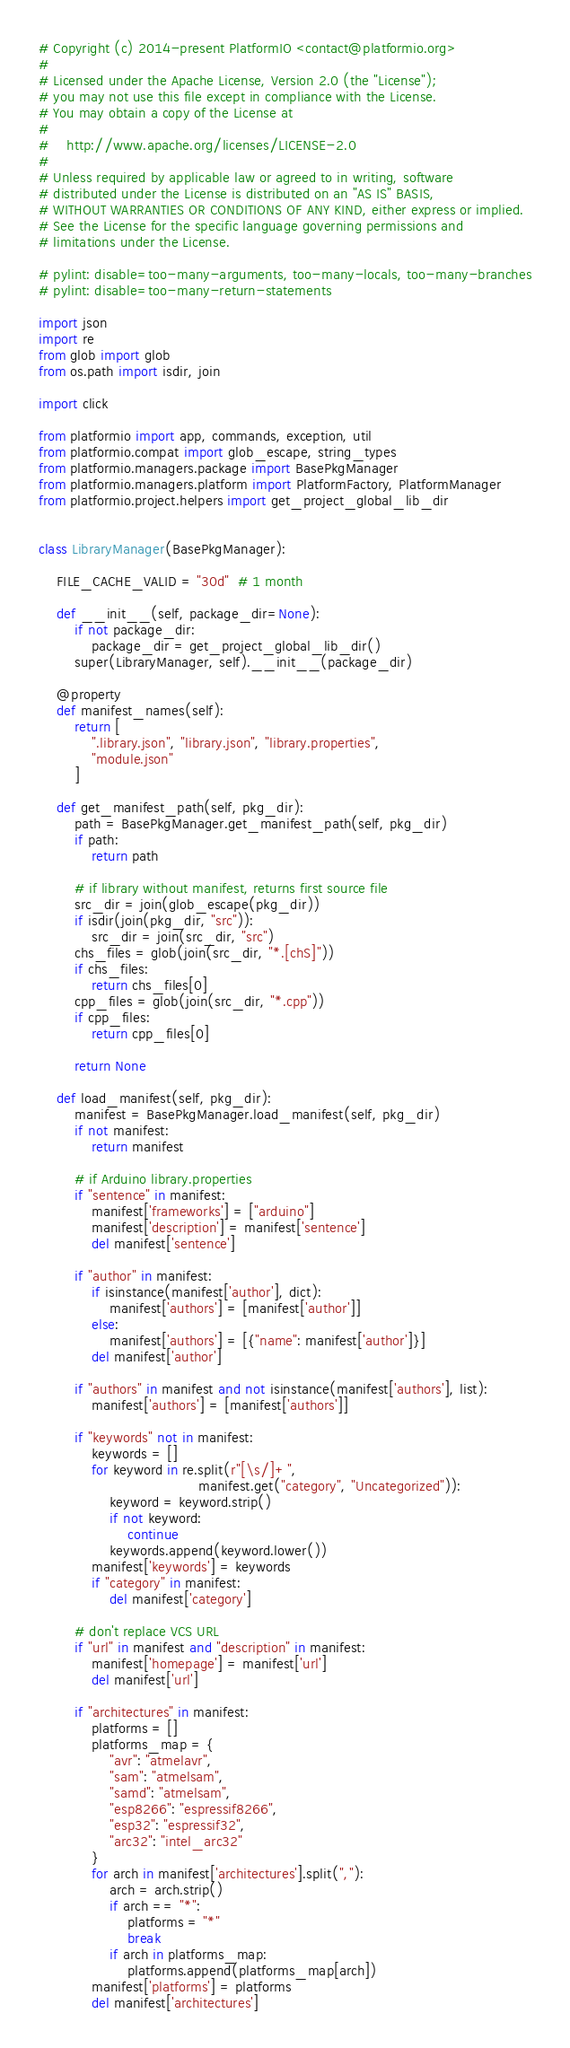<code> <loc_0><loc_0><loc_500><loc_500><_Python_># Copyright (c) 2014-present PlatformIO <contact@platformio.org>
#
# Licensed under the Apache License, Version 2.0 (the "License");
# you may not use this file except in compliance with the License.
# You may obtain a copy of the License at
#
#    http://www.apache.org/licenses/LICENSE-2.0
#
# Unless required by applicable law or agreed to in writing, software
# distributed under the License is distributed on an "AS IS" BASIS,
# WITHOUT WARRANTIES OR CONDITIONS OF ANY KIND, either express or implied.
# See the License for the specific language governing permissions and
# limitations under the License.

# pylint: disable=too-many-arguments, too-many-locals, too-many-branches
# pylint: disable=too-many-return-statements

import json
import re
from glob import glob
from os.path import isdir, join

import click

from platformio import app, commands, exception, util
from platformio.compat import glob_escape, string_types
from platformio.managers.package import BasePkgManager
from platformio.managers.platform import PlatformFactory, PlatformManager
from platformio.project.helpers import get_project_global_lib_dir


class LibraryManager(BasePkgManager):

    FILE_CACHE_VALID = "30d"  # 1 month

    def __init__(self, package_dir=None):
        if not package_dir:
            package_dir = get_project_global_lib_dir()
        super(LibraryManager, self).__init__(package_dir)

    @property
    def manifest_names(self):
        return [
            ".library.json", "library.json", "library.properties",
            "module.json"
        ]

    def get_manifest_path(self, pkg_dir):
        path = BasePkgManager.get_manifest_path(self, pkg_dir)
        if path:
            return path

        # if library without manifest, returns first source file
        src_dir = join(glob_escape(pkg_dir))
        if isdir(join(pkg_dir, "src")):
            src_dir = join(src_dir, "src")
        chs_files = glob(join(src_dir, "*.[chS]"))
        if chs_files:
            return chs_files[0]
        cpp_files = glob(join(src_dir, "*.cpp"))
        if cpp_files:
            return cpp_files[0]

        return None

    def load_manifest(self, pkg_dir):
        manifest = BasePkgManager.load_manifest(self, pkg_dir)
        if not manifest:
            return manifest

        # if Arduino library.properties
        if "sentence" in manifest:
            manifest['frameworks'] = ["arduino"]
            manifest['description'] = manifest['sentence']
            del manifest['sentence']

        if "author" in manifest:
            if isinstance(manifest['author'], dict):
                manifest['authors'] = [manifest['author']]
            else:
                manifest['authors'] = [{"name": manifest['author']}]
            del manifest['author']

        if "authors" in manifest and not isinstance(manifest['authors'], list):
            manifest['authors'] = [manifest['authors']]

        if "keywords" not in manifest:
            keywords = []
            for keyword in re.split(r"[\s/]+",
                                    manifest.get("category", "Uncategorized")):
                keyword = keyword.strip()
                if not keyword:
                    continue
                keywords.append(keyword.lower())
            manifest['keywords'] = keywords
            if "category" in manifest:
                del manifest['category']

        # don't replace VCS URL
        if "url" in manifest and "description" in manifest:
            manifest['homepage'] = manifest['url']
            del manifest['url']

        if "architectures" in manifest:
            platforms = []
            platforms_map = {
                "avr": "atmelavr",
                "sam": "atmelsam",
                "samd": "atmelsam",
                "esp8266": "espressif8266",
                "esp32": "espressif32",
                "arc32": "intel_arc32"
            }
            for arch in manifest['architectures'].split(","):
                arch = arch.strip()
                if arch == "*":
                    platforms = "*"
                    break
                if arch in platforms_map:
                    platforms.append(platforms_map[arch])
            manifest['platforms'] = platforms
            del manifest['architectures']
</code> 